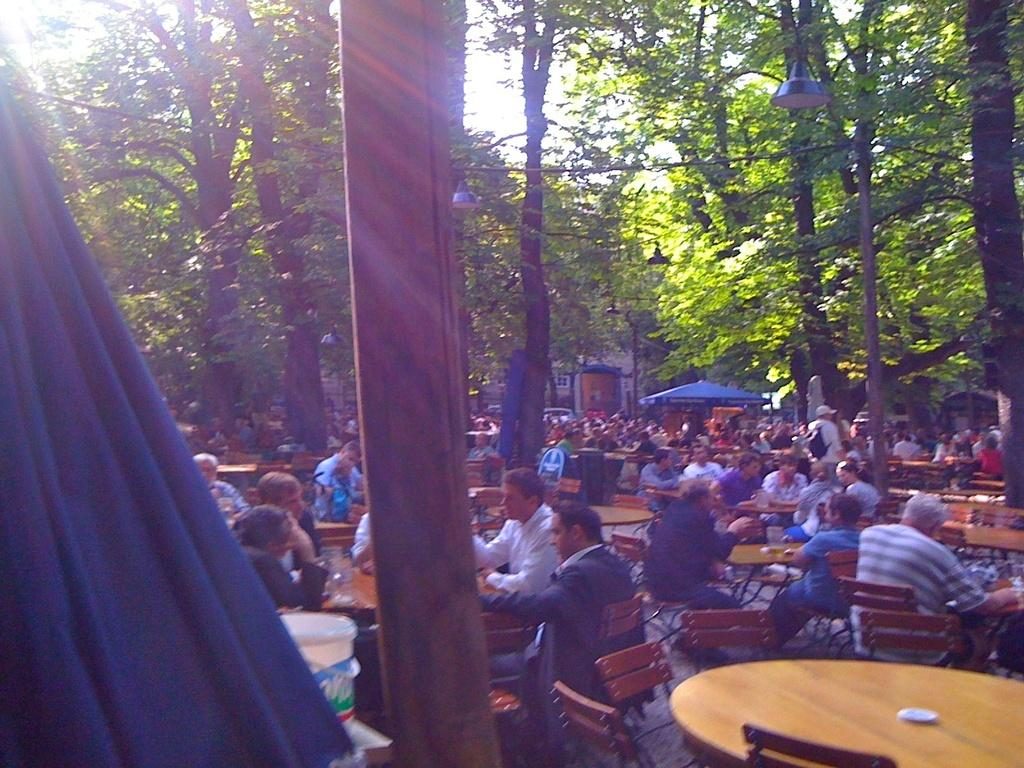What are the people in the image doing? The people in the image are sitting on chairs. How are the chairs arranged in the image? The chairs are arranged around tables. What can be found on the tables in the image? There are things on the tables. What type of natural environment is visible in the image? There are trees visible in the image. What type of temporary shelter is present in the image? There are tents in the image. How many dimes can be seen on the chairs in the image? There are no dimes visible on the chairs in the image. What type of animal is grazing near the tents in the image? There are no animals visible in the image, including goats. 